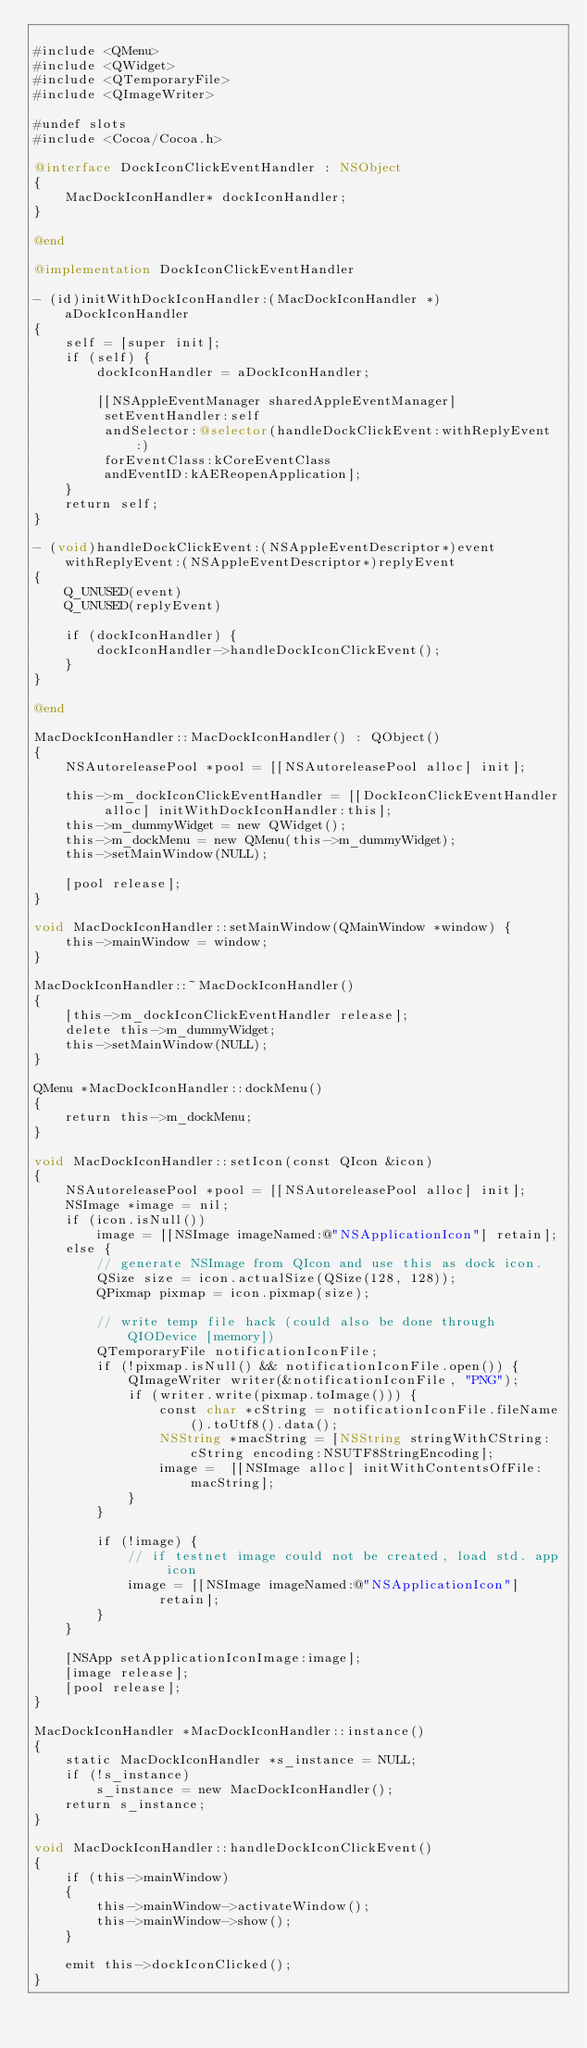Convert code to text. <code><loc_0><loc_0><loc_500><loc_500><_ObjectiveC_>
#include <QMenu>
#include <QWidget>
#include <QTemporaryFile>
#include <QImageWriter>

#undef slots
#include <Cocoa/Cocoa.h>

@interface DockIconClickEventHandler : NSObject
{
    MacDockIconHandler* dockIconHandler;
}

@end

@implementation DockIconClickEventHandler

- (id)initWithDockIconHandler:(MacDockIconHandler *)aDockIconHandler
{
    self = [super init];
    if (self) {
        dockIconHandler = aDockIconHandler;

        [[NSAppleEventManager sharedAppleEventManager]
         setEventHandler:self
         andSelector:@selector(handleDockClickEvent:withReplyEvent:)
         forEventClass:kCoreEventClass
         andEventID:kAEReopenApplication];
    }
    return self;
}

- (void)handleDockClickEvent:(NSAppleEventDescriptor*)event withReplyEvent:(NSAppleEventDescriptor*)replyEvent
{
    Q_UNUSED(event)
    Q_UNUSED(replyEvent)

    if (dockIconHandler) {
        dockIconHandler->handleDockIconClickEvent();
    }
}

@end

MacDockIconHandler::MacDockIconHandler() : QObject()
{
    NSAutoreleasePool *pool = [[NSAutoreleasePool alloc] init];

    this->m_dockIconClickEventHandler = [[DockIconClickEventHandler alloc] initWithDockIconHandler:this];
    this->m_dummyWidget = new QWidget();
    this->m_dockMenu = new QMenu(this->m_dummyWidget);
    this->setMainWindow(NULL);

    [pool release];
}

void MacDockIconHandler::setMainWindow(QMainWindow *window) {
    this->mainWindow = window;
}

MacDockIconHandler::~MacDockIconHandler()
{
    [this->m_dockIconClickEventHandler release];
    delete this->m_dummyWidget;
    this->setMainWindow(NULL);
}

QMenu *MacDockIconHandler::dockMenu()
{
    return this->m_dockMenu;
}

void MacDockIconHandler::setIcon(const QIcon &icon)
{
    NSAutoreleasePool *pool = [[NSAutoreleasePool alloc] init];
    NSImage *image = nil;
    if (icon.isNull())
        image = [[NSImage imageNamed:@"NSApplicationIcon"] retain];
    else {
        // generate NSImage from QIcon and use this as dock icon.
        QSize size = icon.actualSize(QSize(128, 128));
        QPixmap pixmap = icon.pixmap(size);

        // write temp file hack (could also be done through QIODevice [memory])
        QTemporaryFile notificationIconFile;
        if (!pixmap.isNull() && notificationIconFile.open()) {
            QImageWriter writer(&notificationIconFile, "PNG");
            if (writer.write(pixmap.toImage())) {
                const char *cString = notificationIconFile.fileName().toUtf8().data();
                NSString *macString = [NSString stringWithCString:cString encoding:NSUTF8StringEncoding];
                image =  [[NSImage alloc] initWithContentsOfFile:macString];
            }
        }

        if (!image) {
            // if testnet image could not be created, load std. app icon
            image = [[NSImage imageNamed:@"NSApplicationIcon"] retain];
        }
    }

    [NSApp setApplicationIconImage:image];
    [image release];
    [pool release];
}

MacDockIconHandler *MacDockIconHandler::instance()
{
    static MacDockIconHandler *s_instance = NULL;
    if (!s_instance)
        s_instance = new MacDockIconHandler();
    return s_instance;
}

void MacDockIconHandler::handleDockIconClickEvent()
{
    if (this->mainWindow)
    {
        this->mainWindow->activateWindow();
        this->mainWindow->show();
    }

    emit this->dockIconClicked();
}</code> 